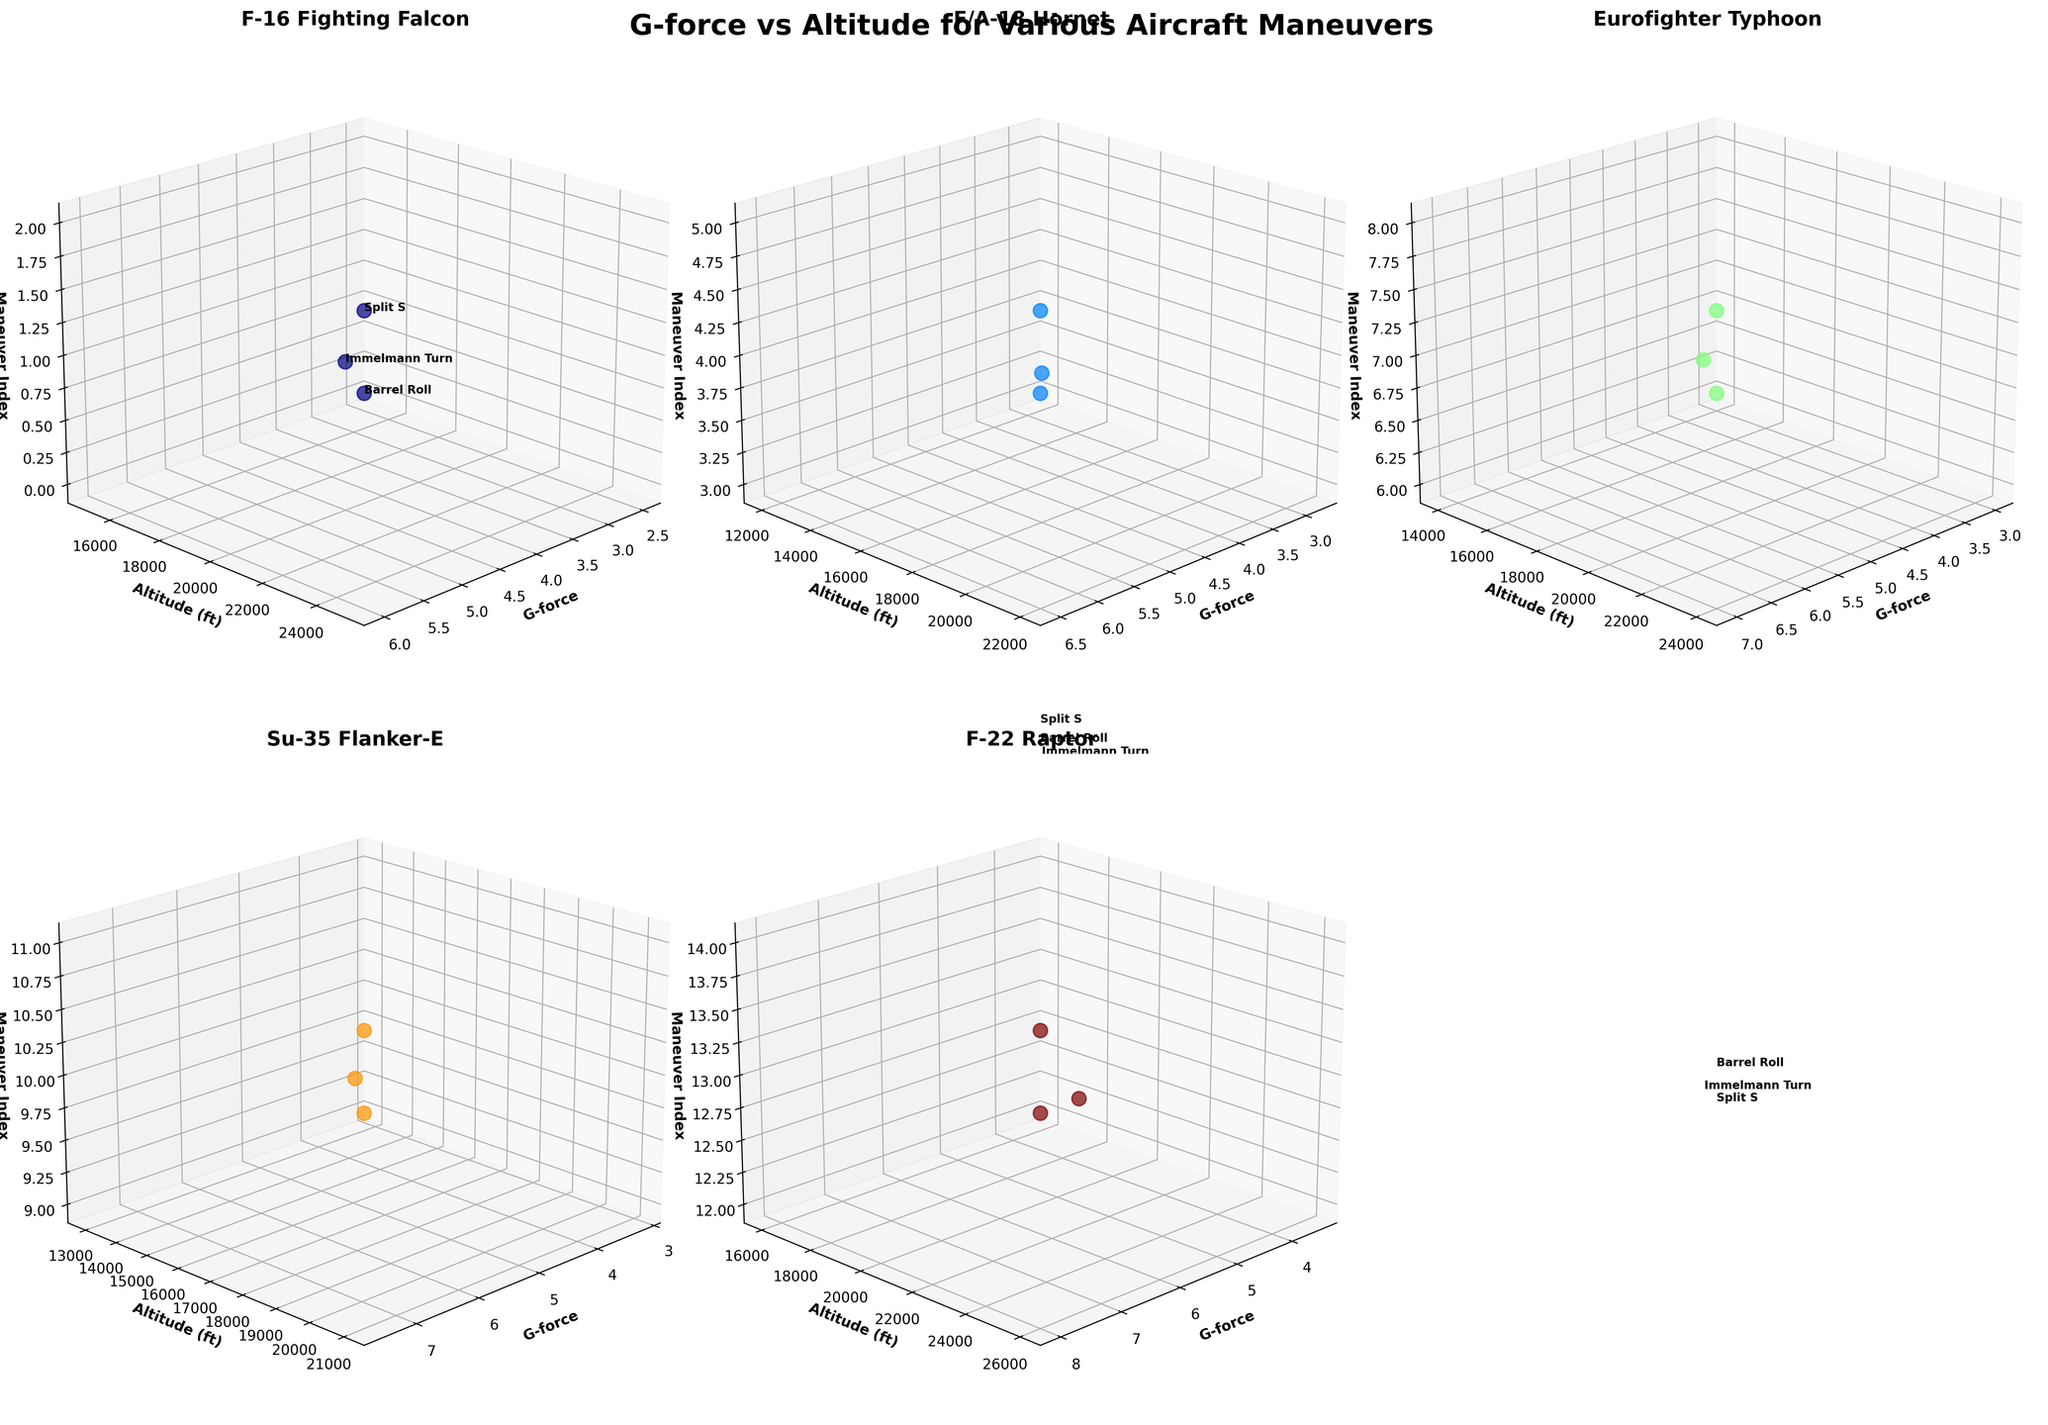How many different aircraft models are depicted in the subplots? By counting the number of unique subplot titles, which correspond to different aircraft models, there are 5 subplots each representing a different aircraft model: F-16 Fighting Falcon, F/A-18 Hornet, Eurofighter Typhoon, Su-35 Flanker-E, and F-22 Raptor.
Answer: 5 What is the highest G-force experienced and which aircraft maneuver pair it with? The highest G-force value can be observed by looking at the G-force axis on each subplot. The highest G-force is 8.0 experienced by the F-22 Raptor during the Split S maneuver.
Answer: 8.0, F-22 Raptor, Split S Which aircraft has the lowest G-force during an Immelmann Turn and what is that G-force value? By examining the G-force values for Immelmann Turn across all subplots, the lowest value is found in the F-16 Fighting Falcon subplot. The G-force during the Immelmann Turn is 4.5.
Answer: F-16 Fighting Falcon, 4.5 Between the Eurofighter Typhoon and the Su-35 Flanker-E, which aircraft demonstrates higher average G-force across all maneuvers? Calculate the average G-force for each aircraft: Eurofighter Typhoon (3.0 + 5.2 + 7.0) / 3 = 5.1 and Su-35 Flanker-E (3.2 + 5.5 + 7.5) / 3 = 5.4. Compare the averages to find that the Su-35 Flanker-E has the higher average G-force.
Answer: Su-35 Flanker-E Which aircraft is performing its maneuvers at the highest average altitude? Calculate the average of altitudes for each aircraft: F-16 Fighting Falcon (15000 + 20000 + 25000) / 3 = 20000, F/A-18 Hornet (12000 + 18000 + 22000) / 3 = 17333.33, Eurofighter Typhoon (14000 + 19000 + 24000) / 3 = 19000, Su-35 Flanker-E (13000 + 17000 + 21000) / 3 = 17000, F-22 Raptor (16000 + 23000 + 26000) / 3 = 21666.67. Compare these averages to find that the F-22 Raptor is the highest.
Answer: F-22 Raptor During which maneuver does the F/A-18 Hornet experience a G-force closest to the average G-force across its maneuvers? First, find the average G-force for the F/A-18 Hornet: (2.8 + 5.0 + 6.5) / 3 = 4.77. Compare this average with the G-force values for each maneuver to see that the Immelmann Turn G-force of 5.0 is the closest.
Answer: Immelmann Turn For each aircraft, which maneuver results in the highest altitude achieved? Inspect each subplot to identify the highest altitude for each aircraft: 
- F-16 Fighting Falcon: Split S (25000 ft)
- F/A-18 Hornet: Split S (22000 ft)
- Eurofighter Typhoon: Split S (24000 ft) 
- Su-35 Flanker-E: Split S (21000 ft)
- F-22 Raptor: Split S (26000 ft) 
The highest altitude for each is during the Split S maneuver.
Answer: Split S (for all aircraft) Which aircraft experiences the maximum average G-force and what is that average value? Calculate average G-force for each aircraft: F-16 Fighting Falcon  (2.5 + 4.5 + 6.0) / 3 = 4.33, F/A-18 Hornet (2.8 + 5.0 + 6.5) / 3 = 4.77, Eurofighter Typhoon (3.0 + 5.2 + 7.0) / 3 = 5.1, Su-35 Flanker-E (3.2 + 5.5 + 7.5) / 3 = 5.4, F-22 Raptor (3.5 + 6.0 + 8.0) / 3 = 5.83. The F-22 Raptor has the highest average of 5.83.
Answer: F-22 Raptor, 5.83 Which aircraft shows the most variation in G-force across different maneuvers? Calculate the range of G-force for each aircraft:
- F-16 Fighting Falcon: 6.0 - 2.5 = 3.5
- F/A-18 Hornet: 6.5 - 2.8 = 3.7
- Eurofighter Typhoon: 7.0 - 3.0 = 4.0
- Su-35 Flanker-E: 7.5 - 3.2 = 4.3
- F-22 Raptor: 8.0 - 3.5 = 4.5
The F-22 Raptor shows the greatest range of G-force variation.
Answer: F-22 Raptor 